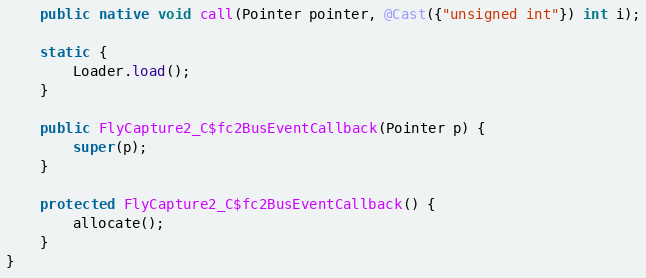Convert code to text. <code><loc_0><loc_0><loc_500><loc_500><_Java_>    public native void call(Pointer pointer, @Cast({"unsigned int"}) int i);

    static {
        Loader.load();
    }

    public FlyCapture2_C$fc2BusEventCallback(Pointer p) {
        super(p);
    }

    protected FlyCapture2_C$fc2BusEventCallback() {
        allocate();
    }
}
</code> 